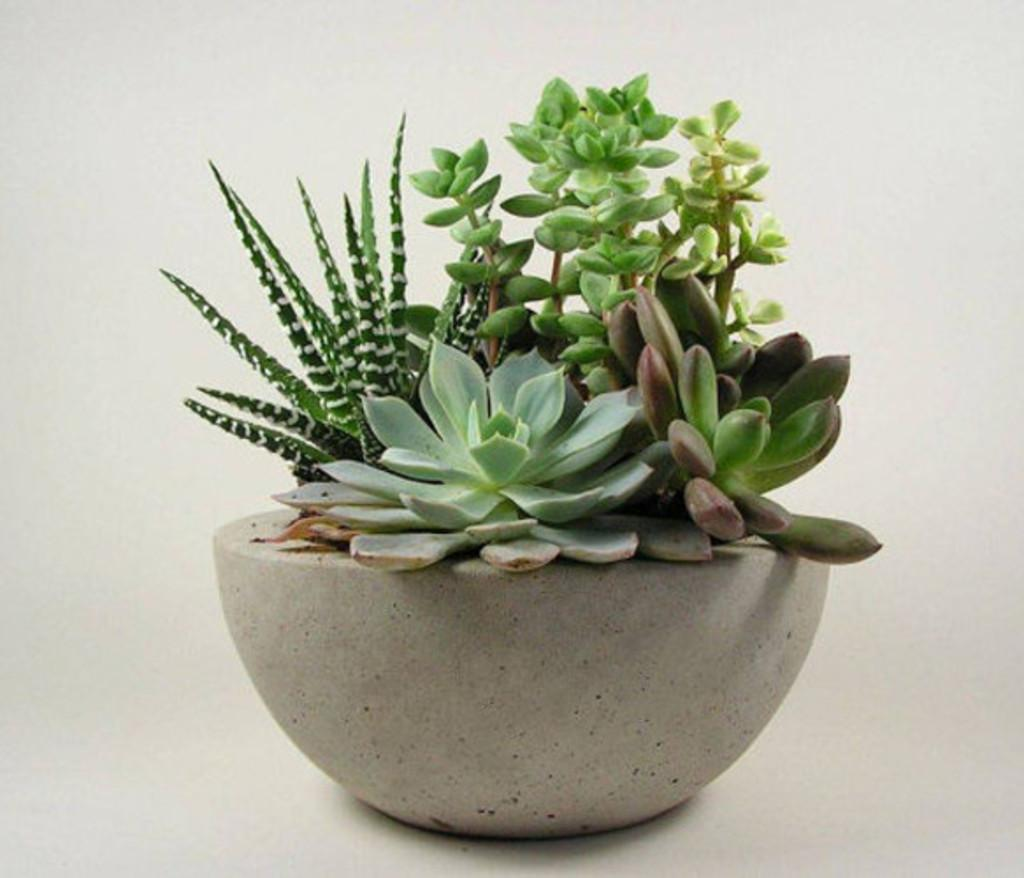What object is present in the image that is typically used for holding plants? There is a plant pot in the image. Where is the plant pot located? The plant pot is on the floor. What type of mint can be seen growing inside the drawer in the image? There is no drawer or mint present in the image; it only features a plant pot on the floor. 